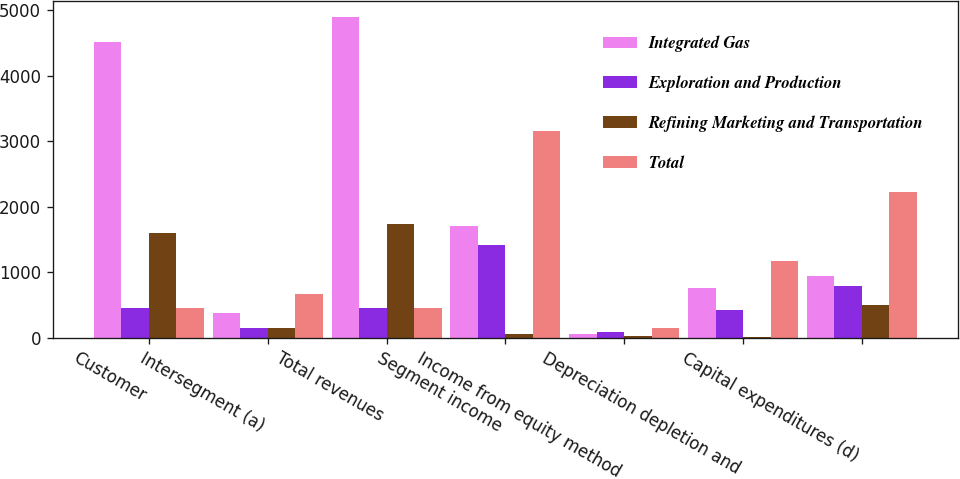<chart> <loc_0><loc_0><loc_500><loc_500><stacked_bar_chart><ecel><fcel>Customer<fcel>Intersegment (a)<fcel>Total revenues<fcel>Segment income<fcel>Income from equity method<fcel>Depreciation depletion and<fcel>Capital expenditures (d)<nl><fcel>Integrated Gas<fcel>4519<fcel>370<fcel>4897<fcel>1696<fcel>50<fcel>750<fcel>944<nl><fcel>Exploration and Production<fcel>453<fcel>152<fcel>453<fcel>1406<fcel>82<fcel>416<fcel>784<nl><fcel>Refining Marketing and Transportation<fcel>1593<fcel>146<fcel>1739<fcel>48<fcel>21<fcel>8<fcel>490<nl><fcel>Total<fcel>453<fcel>668<fcel>453<fcel>3150<fcel>153<fcel>1174<fcel>2218<nl></chart> 